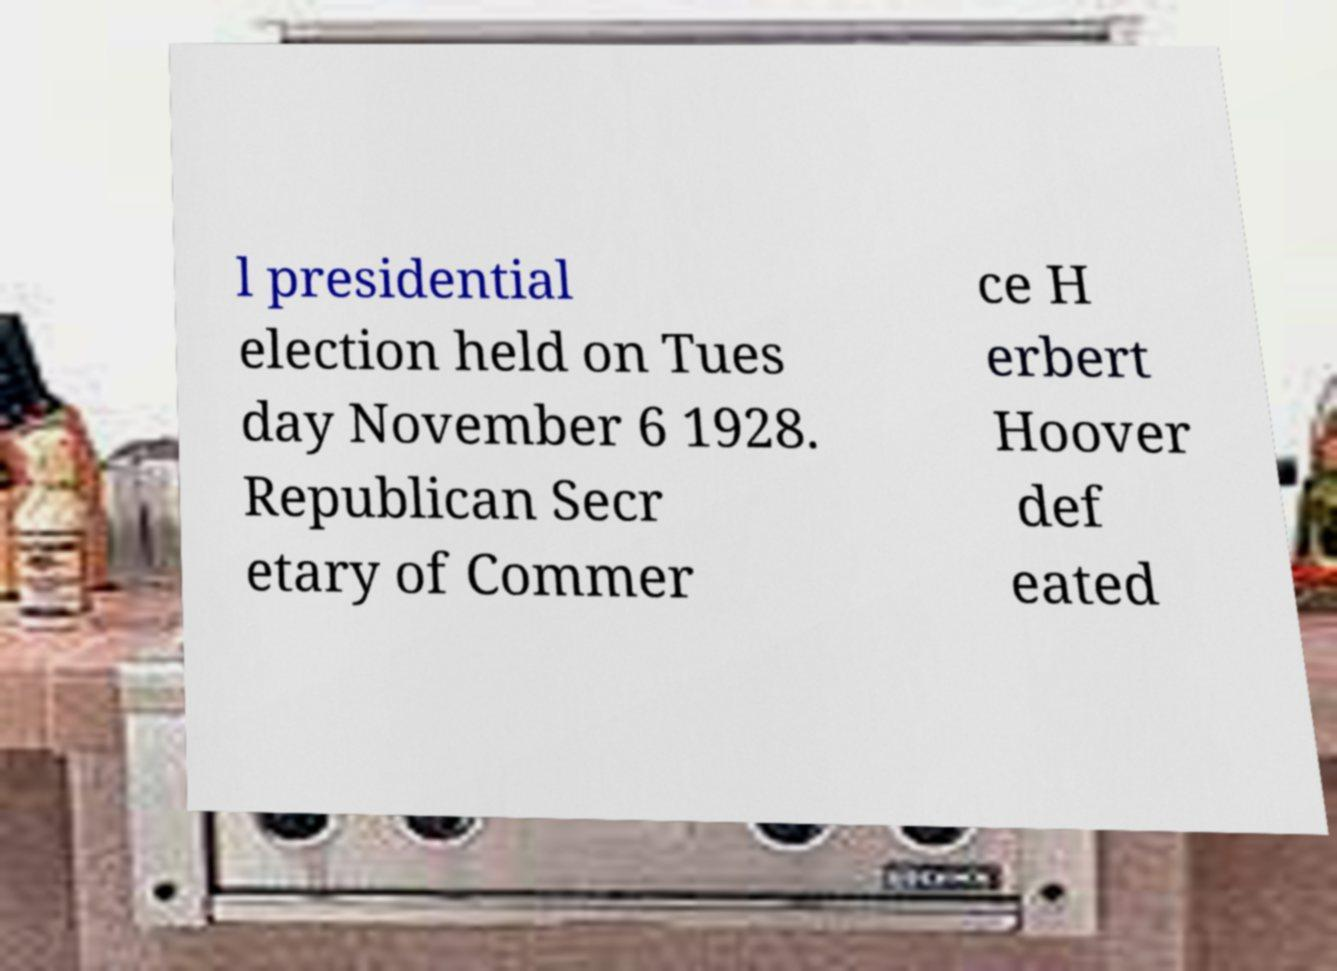What messages or text are displayed in this image? I need them in a readable, typed format. l presidential election held on Tues day November 6 1928. Republican Secr etary of Commer ce H erbert Hoover def eated 